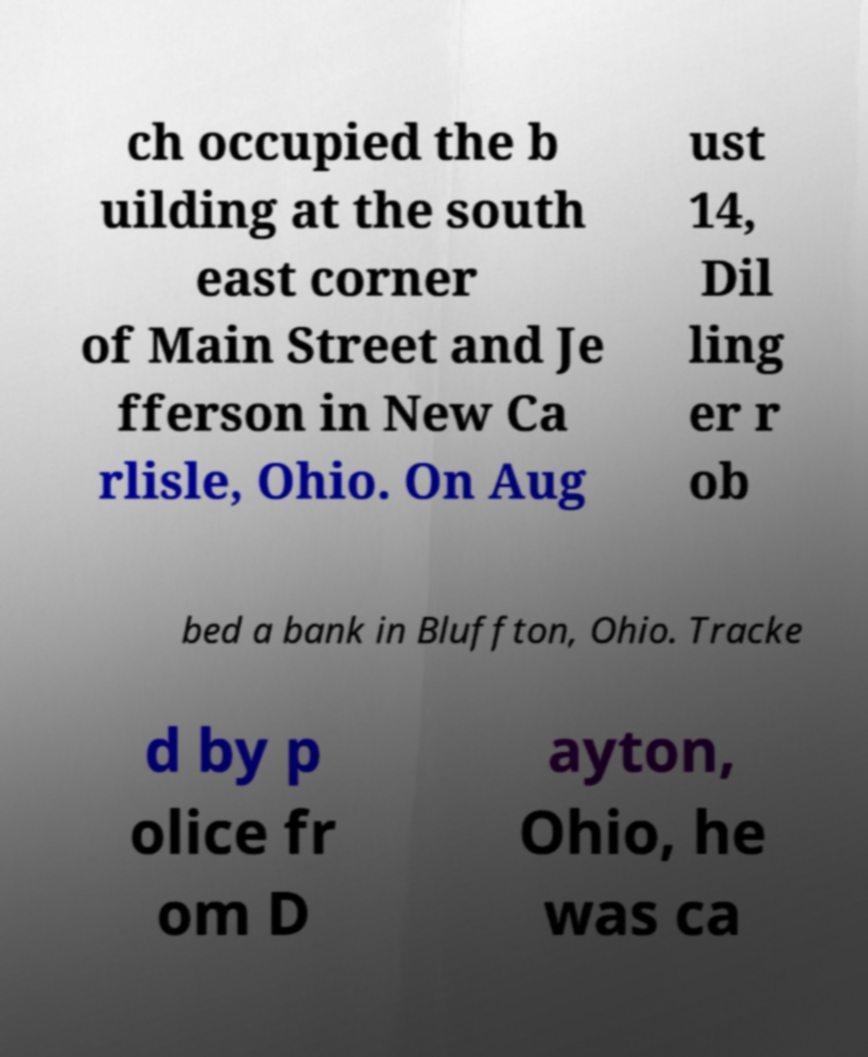Please read and relay the text visible in this image. What does it say? ch occupied the b uilding at the south east corner of Main Street and Je fferson in New Ca rlisle, Ohio. On Aug ust 14, Dil ling er r ob bed a bank in Bluffton, Ohio. Tracke d by p olice fr om D ayton, Ohio, he was ca 